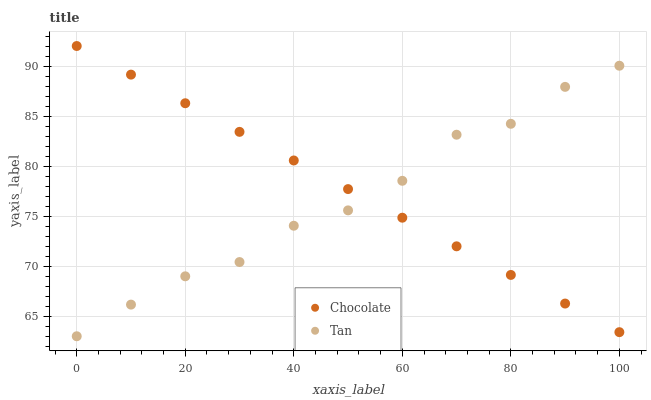Does Tan have the minimum area under the curve?
Answer yes or no. Yes. Does Chocolate have the maximum area under the curve?
Answer yes or no. Yes. Does Chocolate have the minimum area under the curve?
Answer yes or no. No. Is Chocolate the smoothest?
Answer yes or no. Yes. Is Tan the roughest?
Answer yes or no. Yes. Is Chocolate the roughest?
Answer yes or no. No. Does Tan have the lowest value?
Answer yes or no. Yes. Does Chocolate have the lowest value?
Answer yes or no. No. Does Chocolate have the highest value?
Answer yes or no. Yes. Does Chocolate intersect Tan?
Answer yes or no. Yes. Is Chocolate less than Tan?
Answer yes or no. No. Is Chocolate greater than Tan?
Answer yes or no. No. 